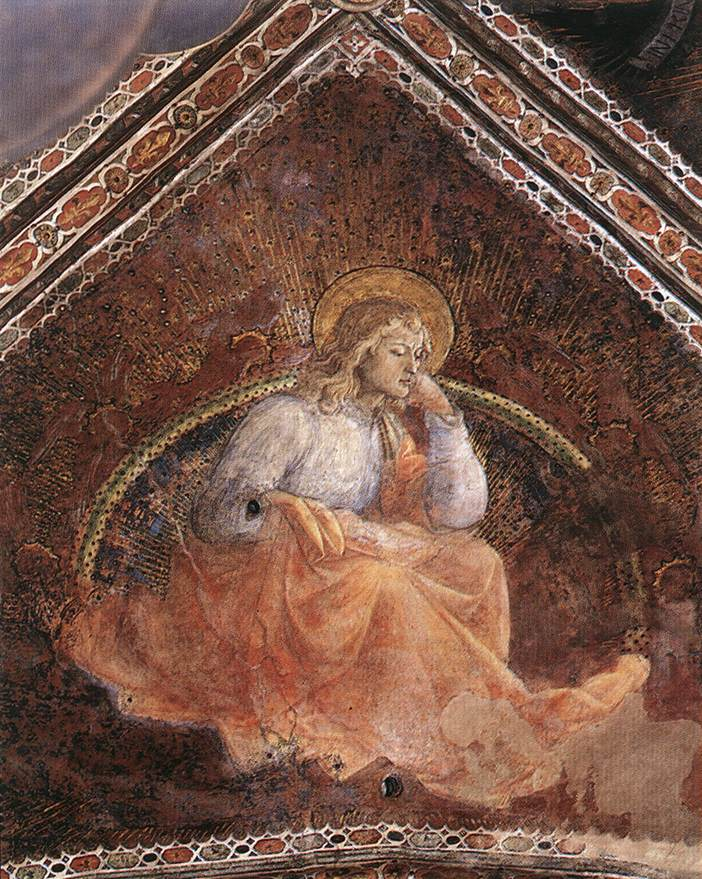Based on the image, create a poem about the scene depicted. In a chapel bathed in twilight’s gentle weave,
An angel ponders, as humans grieve.
Draped in garments of celestial white,
Halo aglow with heaven’s light.
Wings unfurled, a tender grace,
Softly brushes the sacred space.
With eyes of wisdom, it gazes afar,
Contemplating gifts from each guiding star.
Dark red walls in mystic embrace,
Contrast the beauty of its face.
Golden threads embellish the night,
Weaving dreams of divine light.
What thoughts it holds, what dreams it weaves,
Are tales of love and hope retrieved.
In silence, the angel’s heart does speak,
Of worlds renewed, of power’s peak.
Gone are shadows, in its wake,
Hearts will mend and cease to break. 